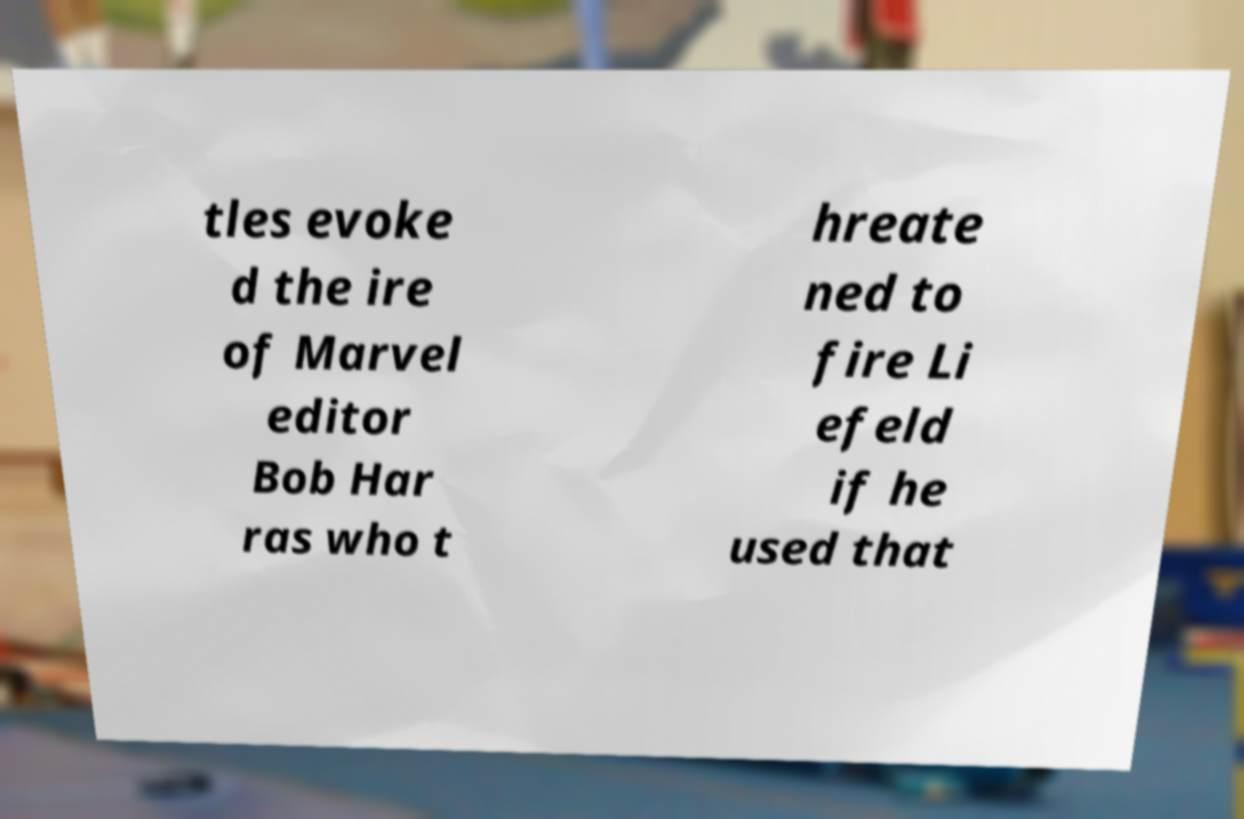Please identify and transcribe the text found in this image. tles evoke d the ire of Marvel editor Bob Har ras who t hreate ned to fire Li efeld if he used that 